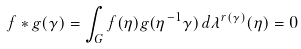Convert formula to latex. <formula><loc_0><loc_0><loc_500><loc_500>f * g ( \gamma ) = \int _ { G } f ( \eta ) g ( \eta ^ { - 1 } \gamma ) \, d \lambda ^ { r ( \gamma ) } ( \eta ) = 0</formula> 